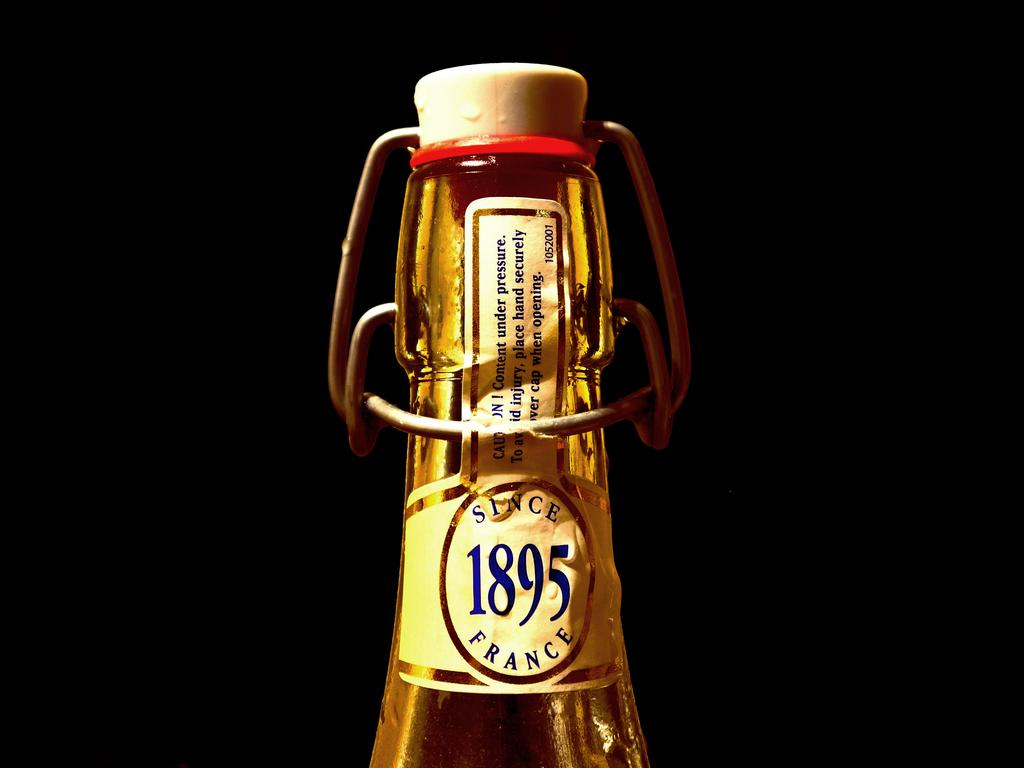What object can be seen in the image? There is a bottle in the image. What is on the bottle? The bottle has a sticker on it. What is covering the opening of the bottle? The bottle has a cap. What can be observed about the background of the image? The background of the image is dark. What type of tongue can be seen sticking out of the bottle in the image? There is no tongue present in the image; it is a bottle with a sticker and a cap. Can you tell me the name of the father of the person who placed the sticker on the bottle? There is no information about the person who placed the sticker on the bottle, nor any indication of their father's name in the image. 